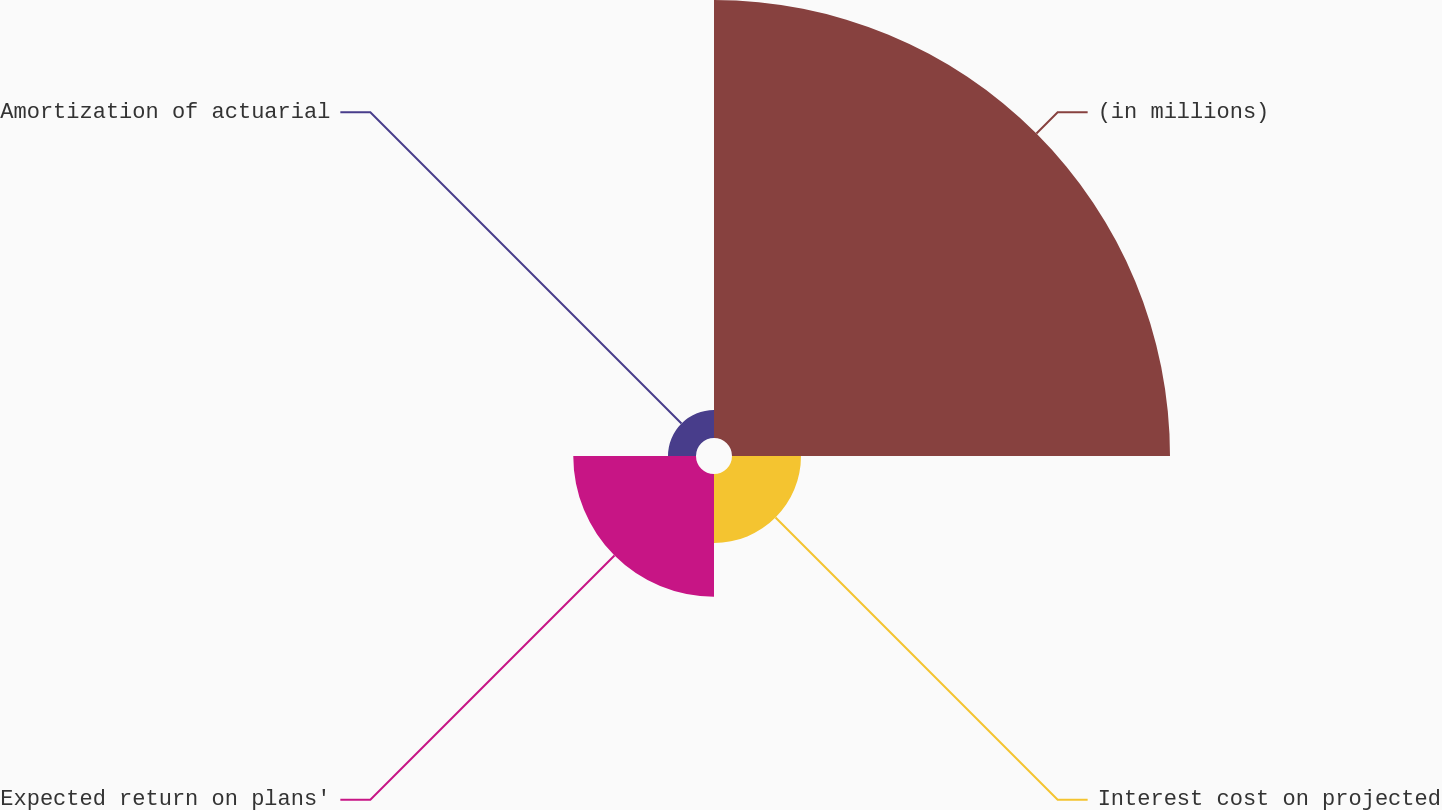Convert chart to OTSL. <chart><loc_0><loc_0><loc_500><loc_500><pie_chart><fcel>(in millions)<fcel>Interest cost on projected<fcel>Expected return on plans'<fcel>Amortization of actuarial<nl><fcel>66.59%<fcel>10.49%<fcel>18.66%<fcel>4.26%<nl></chart> 